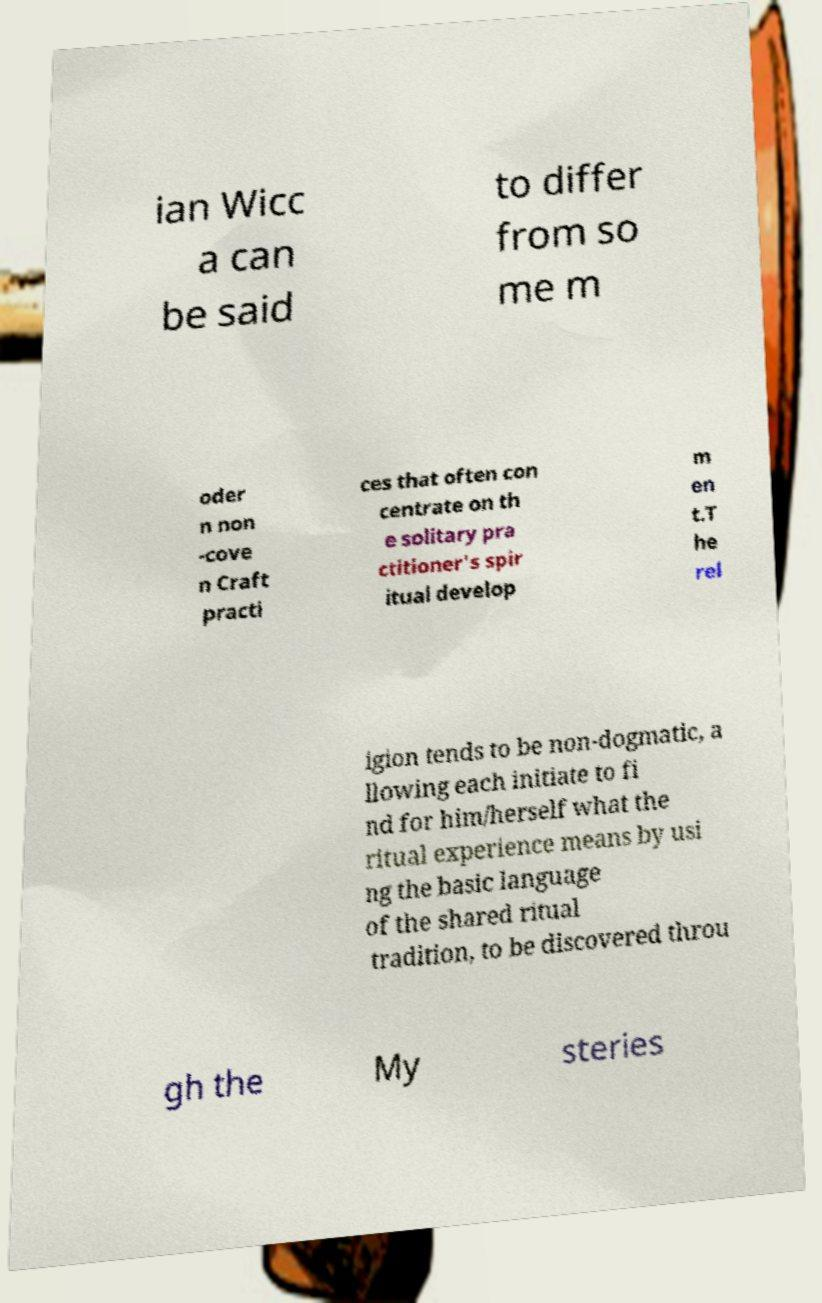Could you assist in decoding the text presented in this image and type it out clearly? ian Wicc a can be said to differ from so me m oder n non -cove n Craft practi ces that often con centrate on th e solitary pra ctitioner's spir itual develop m en t.T he rel igion tends to be non-dogmatic, a llowing each initiate to fi nd for him/herself what the ritual experience means by usi ng the basic language of the shared ritual tradition, to be discovered throu gh the My steries 